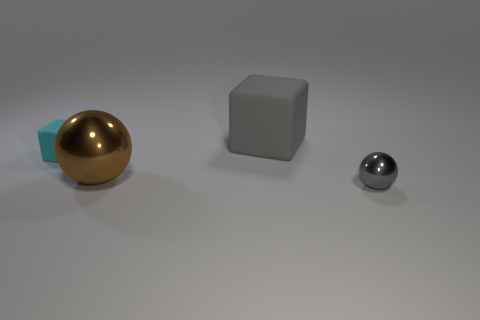Add 3 big blocks. How many objects exist? 7 Add 3 yellow cubes. How many yellow cubes exist? 3 Subtract 0 green spheres. How many objects are left? 4 Subtract all gray metal balls. Subtract all blue metal things. How many objects are left? 3 Add 1 large brown metallic balls. How many large brown metallic balls are left? 2 